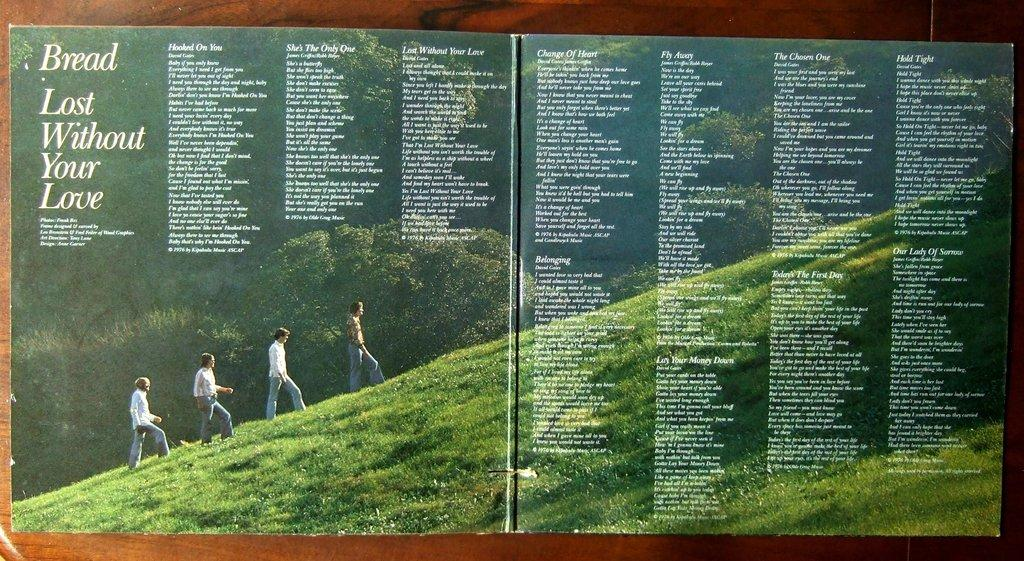How many people are in the image? There are four persons in the image. What are the persons doing in the image? The persons are walking on grass. What type of vegetation can be seen in the image? Trees are present in the image. Is there any text in the image? Yes, there is text in the image. What type of artwork is the image? The image appears to be a wall painting. Can you determine the time of day from the image? The image was likely taken during the day, as there is no indication of darkness or artificial lighting. What type of orange can be seen in the image? There is no orange present in the image. Is there a train visible in the image? No, there is no train visible in the image. 